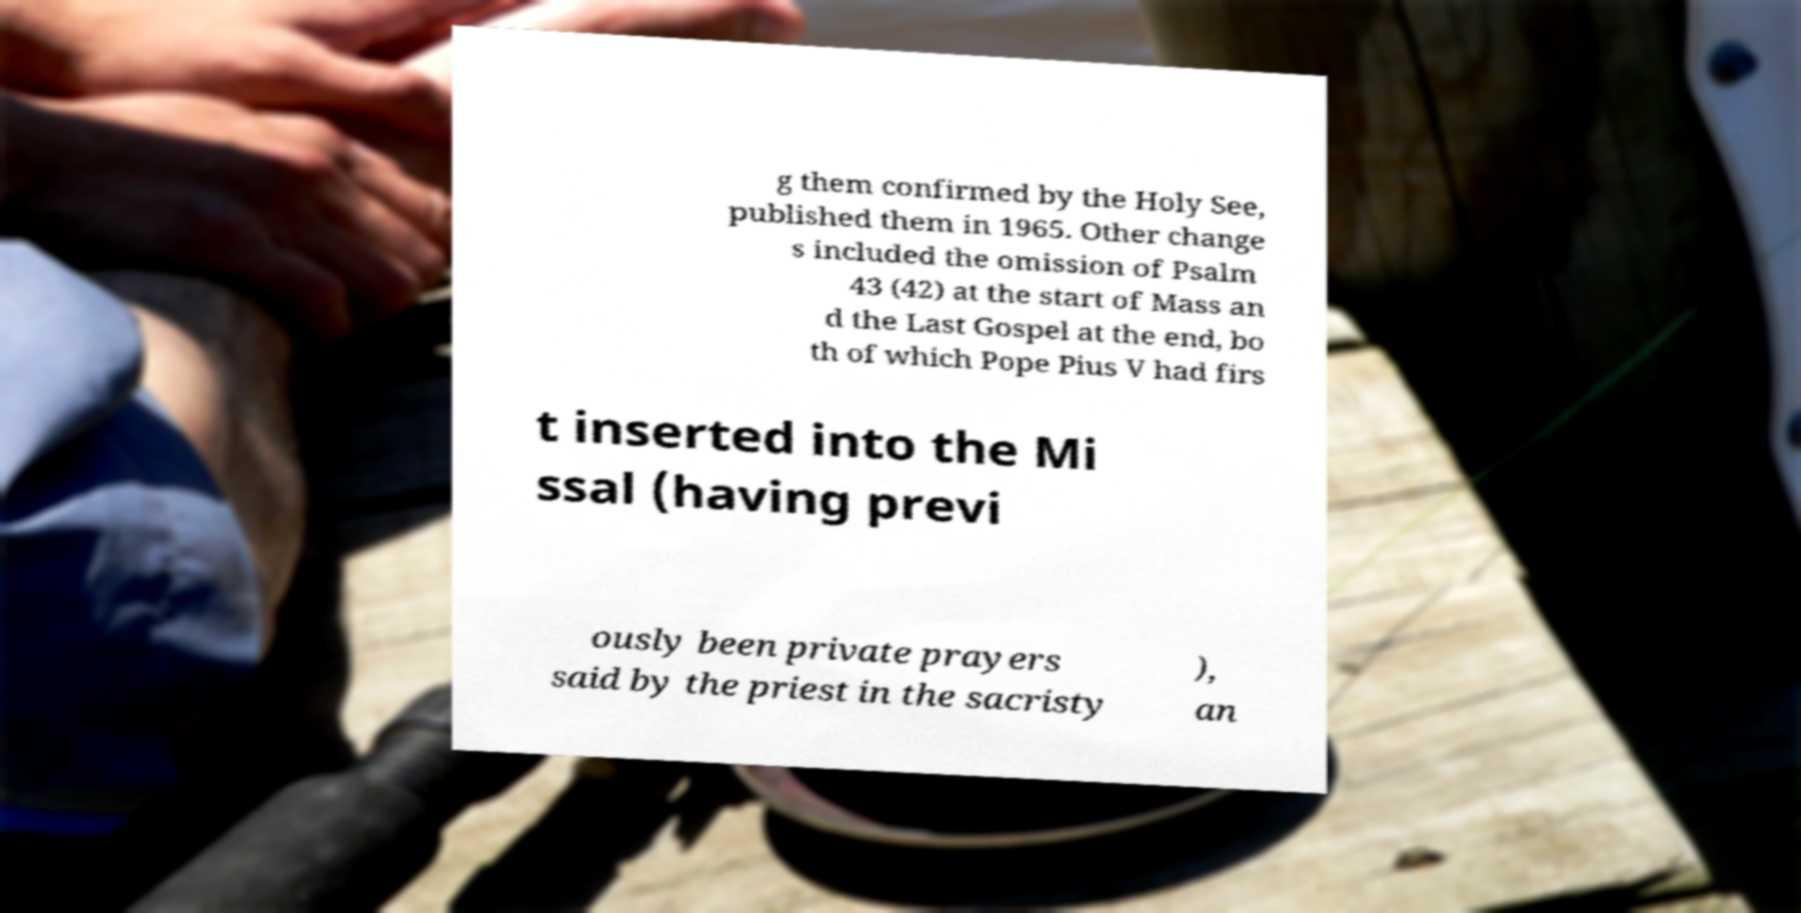Please read and relay the text visible in this image. What does it say? g them confirmed by the Holy See, published them in 1965. Other change s included the omission of Psalm 43 (42) at the start of Mass an d the Last Gospel at the end, bo th of which Pope Pius V had firs t inserted into the Mi ssal (having previ ously been private prayers said by the priest in the sacristy ), an 